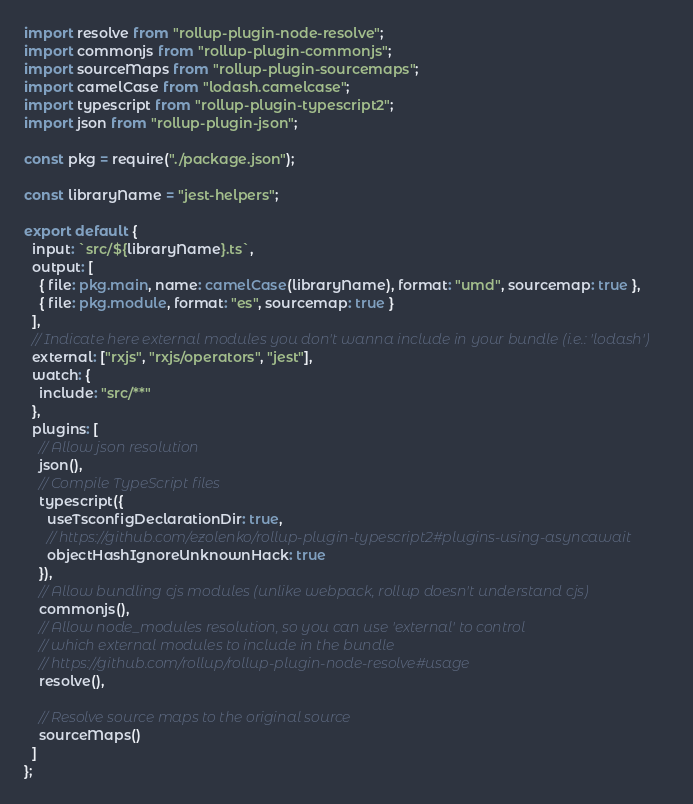Convert code to text. <code><loc_0><loc_0><loc_500><loc_500><_TypeScript_>import resolve from "rollup-plugin-node-resolve";
import commonjs from "rollup-plugin-commonjs";
import sourceMaps from "rollup-plugin-sourcemaps";
import camelCase from "lodash.camelcase";
import typescript from "rollup-plugin-typescript2";
import json from "rollup-plugin-json";

const pkg = require("./package.json");

const libraryName = "jest-helpers";

export default {
  input: `src/${libraryName}.ts`,
  output: [
    { file: pkg.main, name: camelCase(libraryName), format: "umd", sourcemap: true },
    { file: pkg.module, format: "es", sourcemap: true }
  ],
  // Indicate here external modules you don't wanna include in your bundle (i.e.: 'lodash')
  external: ["rxjs", "rxjs/operators", "jest"],
  watch: {
    include: "src/**"
  },
  plugins: [
    // Allow json resolution
    json(),
    // Compile TypeScript files
    typescript({
      useTsconfigDeclarationDir: true,
      // https://github.com/ezolenko/rollup-plugin-typescript2#plugins-using-asyncawait
      objectHashIgnoreUnknownHack: true
    }),
    // Allow bundling cjs modules (unlike webpack, rollup doesn't understand cjs)
    commonjs(),
    // Allow node_modules resolution, so you can use 'external' to control
    // which external modules to include in the bundle
    // https://github.com/rollup/rollup-plugin-node-resolve#usage
    resolve(),

    // Resolve source maps to the original source
    sourceMaps()
  ]
};
</code> 